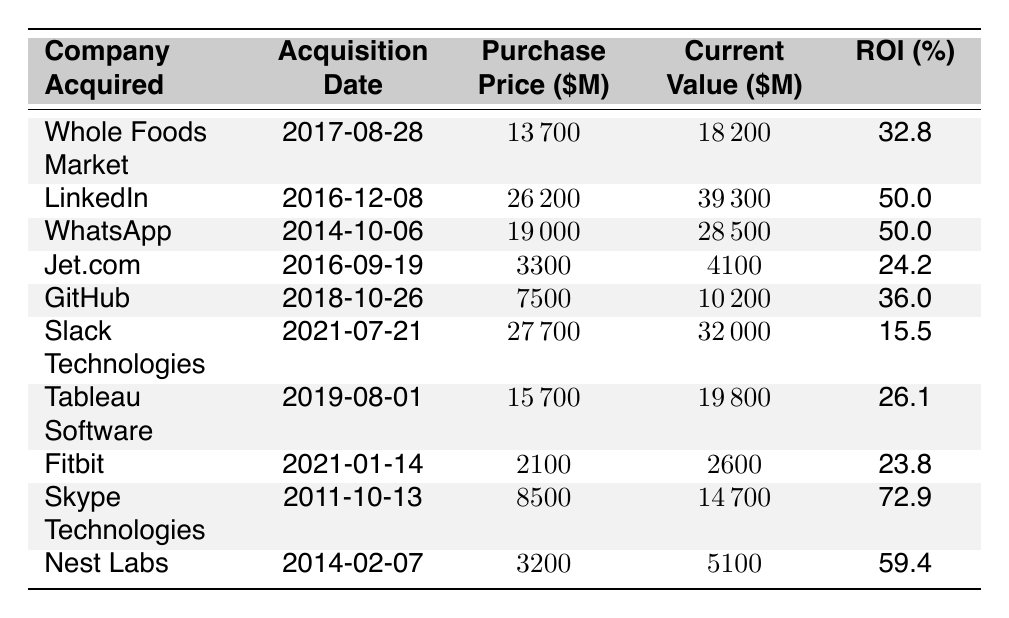What is the current value of LinkedIn? The current value of LinkedIn is listed in the table under the "Current Value ($M)" column for the row corresponding to LinkedIn. It shows 39300.
Answer: 39300 Which company had the highest ROI? To find the highest ROI, I look through the "ROI (%)" column and see the values listed. Skype Technologies has the highest ROI at 72.9%.
Answer: Skype Technologies What was the purchase price of Jet.com? The purchase price for Jet.com is found in the "Purchase Price ($M)" column in its respective row. The value is 3300.
Answer: 3300 What’s the average ROI for all acquisitions in the table? To calculate the average ROI, I sum the ROI values: 32.8 + 50.0 + 50.0 + 24.2 + 36.0 + 15.5 + 26.1 + 23.8 + 72.9 + 59.4 =  364.7. There are 10 companies, so I divide this sum by 10 to get the average: 364.7 / 10 = 36.47.
Answer: 36.47 Was the current value of GitHub greater than its purchase price? Comparing the "Current Value ($M)" of GitHub (10200) with the "Purchase Price ($M)" (7500), I see that 10200 is greater than 7500. Therefore, the current value is indeed greater than the purchase price.
Answer: Yes Which two acquisitions had the same ROI of 50%? Looking at the "ROI (%)" column, I find that both LinkedIn and WhatsApp have an ROI of 50.0%. These are the two acquisitions that share this ROI value.
Answer: LinkedIn and WhatsApp How much greater is the current value of Nest Labs compared to its purchase price? To find the difference, I subtract the "Purchase Price ($M)" of Nest Labs (3200) from its "Current Value ($M)" (5100). Thus, 5100 - 3200 = 1900.
Answer: 1900 What percentage of the companies have an ROI greater than 30%? First, I check the "ROI (%)" column. The companies Whole Foods Market, LinkedIn, WhatsApp, GitHub, and Nest Labs have ROIs greater than 30%. This is a total of 5 companies. Out of 10 total acquisitions, that gives a percentage of (5/10)*100 = 50%.
Answer: 50% 